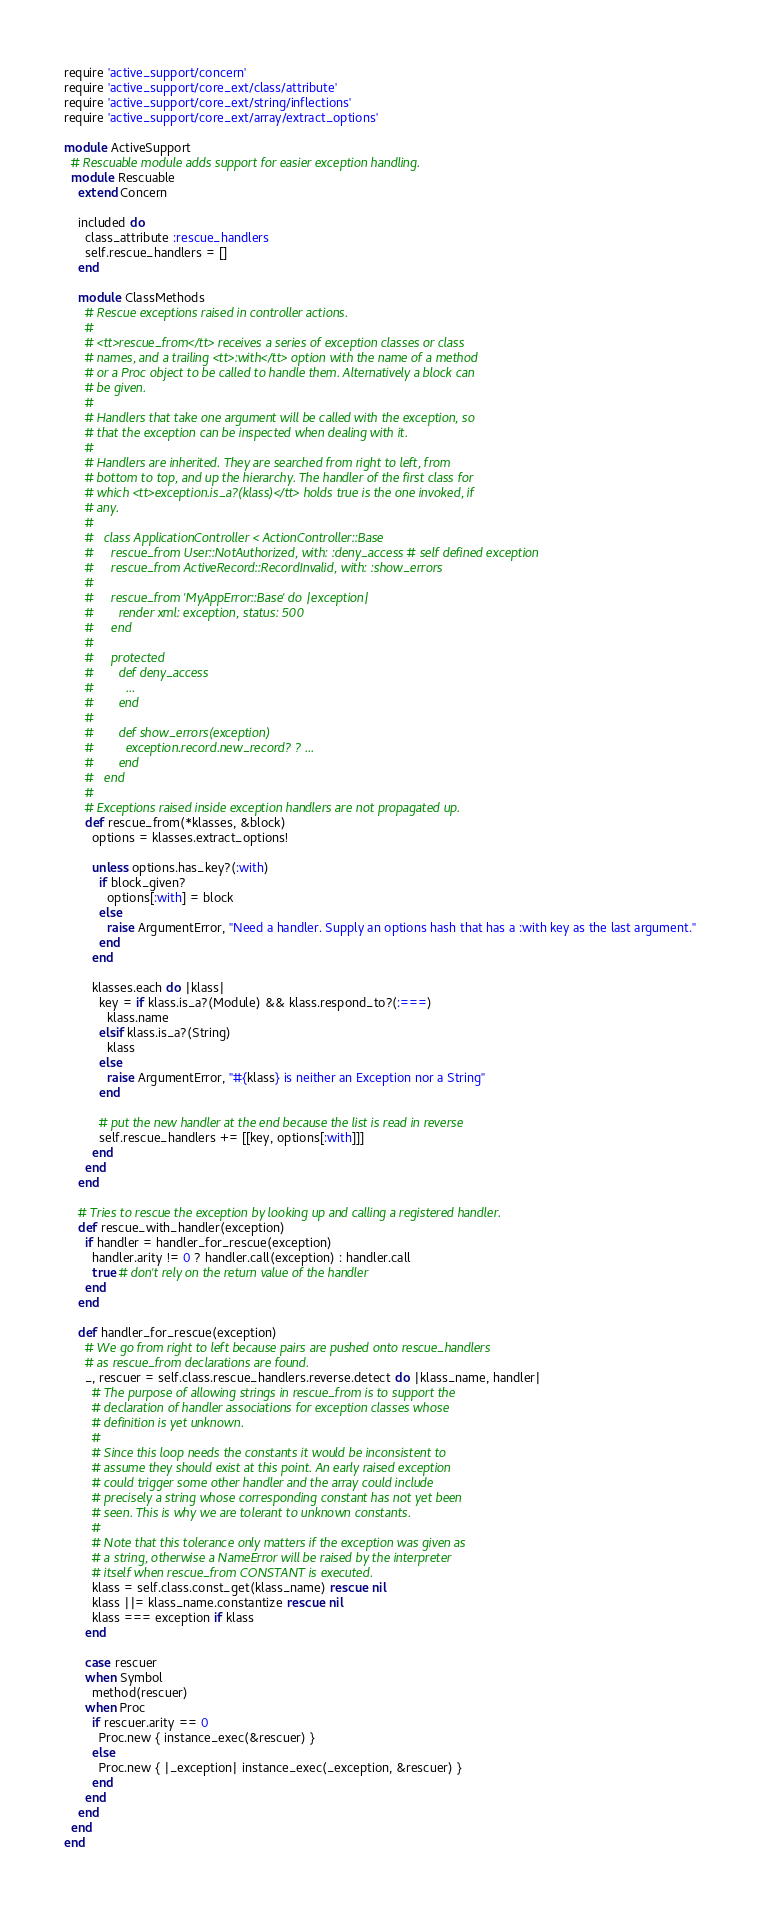Convert code to text. <code><loc_0><loc_0><loc_500><loc_500><_Ruby_>require 'active_support/concern'
require 'active_support/core_ext/class/attribute'
require 'active_support/core_ext/string/inflections'
require 'active_support/core_ext/array/extract_options'

module ActiveSupport
  # Rescuable module adds support for easier exception handling.
  module Rescuable
    extend Concern

    included do
      class_attribute :rescue_handlers
      self.rescue_handlers = []
    end

    module ClassMethods
      # Rescue exceptions raised in controller actions.
      #
      # <tt>rescue_from</tt> receives a series of exception classes or class
      # names, and a trailing <tt>:with</tt> option with the name of a method
      # or a Proc object to be called to handle them. Alternatively a block can
      # be given.
      #
      # Handlers that take one argument will be called with the exception, so
      # that the exception can be inspected when dealing with it.
      #
      # Handlers are inherited. They are searched from right to left, from
      # bottom to top, and up the hierarchy. The handler of the first class for
      # which <tt>exception.is_a?(klass)</tt> holds true is the one invoked, if
      # any.
      #
      #   class ApplicationController < ActionController::Base
      #     rescue_from User::NotAuthorized, with: :deny_access # self defined exception
      #     rescue_from ActiveRecord::RecordInvalid, with: :show_errors
      #
      #     rescue_from 'MyAppError::Base' do |exception|
      #       render xml: exception, status: 500
      #     end
      #
      #     protected
      #       def deny_access
      #         ...
      #       end
      #
      #       def show_errors(exception)
      #         exception.record.new_record? ? ...
      #       end
      #   end
      #
      # Exceptions raised inside exception handlers are not propagated up.
      def rescue_from(*klasses, &block)
        options = klasses.extract_options!

        unless options.has_key?(:with)
          if block_given?
            options[:with] = block
          else
            raise ArgumentError, "Need a handler. Supply an options hash that has a :with key as the last argument."
          end
        end

        klasses.each do |klass|
          key = if klass.is_a?(Module) && klass.respond_to?(:===)
            klass.name
          elsif klass.is_a?(String)
            klass
          else
            raise ArgumentError, "#{klass} is neither an Exception nor a String"
          end

          # put the new handler at the end because the list is read in reverse
          self.rescue_handlers += [[key, options[:with]]]
        end
      end
    end

    # Tries to rescue the exception by looking up and calling a registered handler.
    def rescue_with_handler(exception)
      if handler = handler_for_rescue(exception)
        handler.arity != 0 ? handler.call(exception) : handler.call
        true # don't rely on the return value of the handler
      end
    end

    def handler_for_rescue(exception)
      # We go from right to left because pairs are pushed onto rescue_handlers
      # as rescue_from declarations are found.
      _, rescuer = self.class.rescue_handlers.reverse.detect do |klass_name, handler|
        # The purpose of allowing strings in rescue_from is to support the
        # declaration of handler associations for exception classes whose
        # definition is yet unknown.
        #
        # Since this loop needs the constants it would be inconsistent to
        # assume they should exist at this point. An early raised exception
        # could trigger some other handler and the array could include
        # precisely a string whose corresponding constant has not yet been
        # seen. This is why we are tolerant to unknown constants.
        #
        # Note that this tolerance only matters if the exception was given as
        # a string, otherwise a NameError will be raised by the interpreter
        # itself when rescue_from CONSTANT is executed.
        klass = self.class.const_get(klass_name) rescue nil
        klass ||= klass_name.constantize rescue nil
        klass === exception if klass
      end

      case rescuer
      when Symbol
        method(rescuer)
      when Proc
        if rescuer.arity == 0
          Proc.new { instance_exec(&rescuer) }
        else
          Proc.new { |_exception| instance_exec(_exception, &rescuer) }
        end
      end
    end
  end
end
</code> 